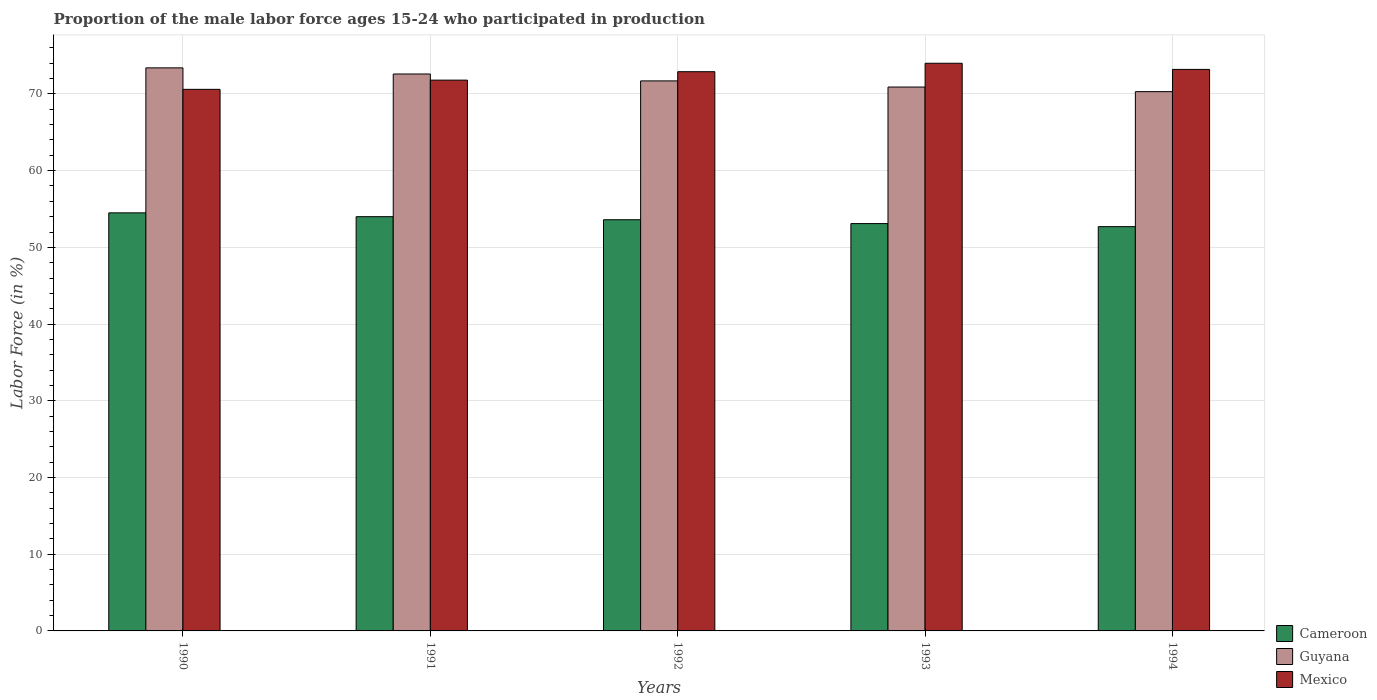How many different coloured bars are there?
Your answer should be very brief. 3. How many groups of bars are there?
Offer a very short reply. 5. Are the number of bars per tick equal to the number of legend labels?
Provide a succinct answer. Yes. Are the number of bars on each tick of the X-axis equal?
Your response must be concise. Yes. How many bars are there on the 4th tick from the right?
Your response must be concise. 3. In how many cases, is the number of bars for a given year not equal to the number of legend labels?
Your response must be concise. 0. What is the proportion of the male labor force who participated in production in Cameroon in 1992?
Your answer should be compact. 53.6. Across all years, what is the maximum proportion of the male labor force who participated in production in Guyana?
Your response must be concise. 73.4. Across all years, what is the minimum proportion of the male labor force who participated in production in Cameroon?
Ensure brevity in your answer.  52.7. In which year was the proportion of the male labor force who participated in production in Mexico minimum?
Your response must be concise. 1990. What is the total proportion of the male labor force who participated in production in Mexico in the graph?
Your answer should be compact. 362.5. What is the difference between the proportion of the male labor force who participated in production in Guyana in 1992 and that in 1993?
Your response must be concise. 0.8. What is the difference between the proportion of the male labor force who participated in production in Mexico in 1992 and the proportion of the male labor force who participated in production in Cameroon in 1990?
Keep it short and to the point. 18.4. What is the average proportion of the male labor force who participated in production in Mexico per year?
Provide a succinct answer. 72.5. In the year 1994, what is the difference between the proportion of the male labor force who participated in production in Guyana and proportion of the male labor force who participated in production in Cameroon?
Make the answer very short. 17.6. In how many years, is the proportion of the male labor force who participated in production in Mexico greater than 24 %?
Your answer should be compact. 5. What is the ratio of the proportion of the male labor force who participated in production in Guyana in 1990 to that in 1991?
Provide a short and direct response. 1.01. What is the difference between the highest and the lowest proportion of the male labor force who participated in production in Guyana?
Ensure brevity in your answer.  3.1. In how many years, is the proportion of the male labor force who participated in production in Mexico greater than the average proportion of the male labor force who participated in production in Mexico taken over all years?
Your response must be concise. 3. What does the 2nd bar from the left in 1993 represents?
Provide a succinct answer. Guyana. What does the 1st bar from the right in 1992 represents?
Provide a short and direct response. Mexico. Is it the case that in every year, the sum of the proportion of the male labor force who participated in production in Mexico and proportion of the male labor force who participated in production in Guyana is greater than the proportion of the male labor force who participated in production in Cameroon?
Your answer should be compact. Yes. How many bars are there?
Keep it short and to the point. 15. What is the difference between two consecutive major ticks on the Y-axis?
Your answer should be very brief. 10. Are the values on the major ticks of Y-axis written in scientific E-notation?
Your answer should be compact. No. Does the graph contain grids?
Offer a very short reply. Yes. Where does the legend appear in the graph?
Make the answer very short. Bottom right. How are the legend labels stacked?
Your answer should be compact. Vertical. What is the title of the graph?
Ensure brevity in your answer.  Proportion of the male labor force ages 15-24 who participated in production. Does "East Asia (developing only)" appear as one of the legend labels in the graph?
Ensure brevity in your answer.  No. What is the Labor Force (in %) in Cameroon in 1990?
Make the answer very short. 54.5. What is the Labor Force (in %) in Guyana in 1990?
Your answer should be compact. 73.4. What is the Labor Force (in %) in Mexico in 1990?
Provide a succinct answer. 70.6. What is the Labor Force (in %) in Cameroon in 1991?
Ensure brevity in your answer.  54. What is the Labor Force (in %) in Guyana in 1991?
Make the answer very short. 72.6. What is the Labor Force (in %) in Mexico in 1991?
Give a very brief answer. 71.8. What is the Labor Force (in %) in Cameroon in 1992?
Offer a terse response. 53.6. What is the Labor Force (in %) in Guyana in 1992?
Provide a succinct answer. 71.7. What is the Labor Force (in %) of Mexico in 1992?
Provide a short and direct response. 72.9. What is the Labor Force (in %) in Cameroon in 1993?
Your response must be concise. 53.1. What is the Labor Force (in %) of Guyana in 1993?
Offer a very short reply. 70.9. What is the Labor Force (in %) in Mexico in 1993?
Give a very brief answer. 74. What is the Labor Force (in %) of Cameroon in 1994?
Give a very brief answer. 52.7. What is the Labor Force (in %) in Guyana in 1994?
Offer a very short reply. 70.3. What is the Labor Force (in %) of Mexico in 1994?
Offer a very short reply. 73.2. Across all years, what is the maximum Labor Force (in %) in Cameroon?
Give a very brief answer. 54.5. Across all years, what is the maximum Labor Force (in %) of Guyana?
Ensure brevity in your answer.  73.4. Across all years, what is the minimum Labor Force (in %) in Cameroon?
Make the answer very short. 52.7. Across all years, what is the minimum Labor Force (in %) in Guyana?
Your answer should be very brief. 70.3. Across all years, what is the minimum Labor Force (in %) of Mexico?
Offer a terse response. 70.6. What is the total Labor Force (in %) in Cameroon in the graph?
Keep it short and to the point. 267.9. What is the total Labor Force (in %) in Guyana in the graph?
Offer a very short reply. 358.9. What is the total Labor Force (in %) of Mexico in the graph?
Your answer should be compact. 362.5. What is the difference between the Labor Force (in %) in Guyana in 1990 and that in 1991?
Your answer should be compact. 0.8. What is the difference between the Labor Force (in %) of Guyana in 1990 and that in 1992?
Make the answer very short. 1.7. What is the difference between the Labor Force (in %) in Mexico in 1990 and that in 1992?
Offer a very short reply. -2.3. What is the difference between the Labor Force (in %) of Cameroon in 1990 and that in 1993?
Offer a very short reply. 1.4. What is the difference between the Labor Force (in %) of Guyana in 1990 and that in 1993?
Keep it short and to the point. 2.5. What is the difference between the Labor Force (in %) of Mexico in 1990 and that in 1993?
Make the answer very short. -3.4. What is the difference between the Labor Force (in %) of Guyana in 1990 and that in 1994?
Your answer should be compact. 3.1. What is the difference between the Labor Force (in %) in Mexico in 1990 and that in 1994?
Ensure brevity in your answer.  -2.6. What is the difference between the Labor Force (in %) of Guyana in 1991 and that in 1992?
Offer a terse response. 0.9. What is the difference between the Labor Force (in %) of Mexico in 1991 and that in 1992?
Your response must be concise. -1.1. What is the difference between the Labor Force (in %) in Guyana in 1991 and that in 1993?
Your answer should be very brief. 1.7. What is the difference between the Labor Force (in %) in Cameroon in 1991 and that in 1994?
Your answer should be very brief. 1.3. What is the difference between the Labor Force (in %) in Guyana in 1991 and that in 1994?
Keep it short and to the point. 2.3. What is the difference between the Labor Force (in %) of Mexico in 1991 and that in 1994?
Give a very brief answer. -1.4. What is the difference between the Labor Force (in %) in Cameroon in 1992 and that in 1993?
Provide a succinct answer. 0.5. What is the difference between the Labor Force (in %) in Cameroon in 1993 and that in 1994?
Offer a very short reply. 0.4. What is the difference between the Labor Force (in %) of Guyana in 1993 and that in 1994?
Ensure brevity in your answer.  0.6. What is the difference between the Labor Force (in %) in Mexico in 1993 and that in 1994?
Your answer should be very brief. 0.8. What is the difference between the Labor Force (in %) of Cameroon in 1990 and the Labor Force (in %) of Guyana in 1991?
Provide a succinct answer. -18.1. What is the difference between the Labor Force (in %) of Cameroon in 1990 and the Labor Force (in %) of Mexico in 1991?
Ensure brevity in your answer.  -17.3. What is the difference between the Labor Force (in %) of Cameroon in 1990 and the Labor Force (in %) of Guyana in 1992?
Your response must be concise. -17.2. What is the difference between the Labor Force (in %) in Cameroon in 1990 and the Labor Force (in %) in Mexico in 1992?
Give a very brief answer. -18.4. What is the difference between the Labor Force (in %) in Cameroon in 1990 and the Labor Force (in %) in Guyana in 1993?
Give a very brief answer. -16.4. What is the difference between the Labor Force (in %) of Cameroon in 1990 and the Labor Force (in %) of Mexico in 1993?
Your response must be concise. -19.5. What is the difference between the Labor Force (in %) of Cameroon in 1990 and the Labor Force (in %) of Guyana in 1994?
Offer a terse response. -15.8. What is the difference between the Labor Force (in %) in Cameroon in 1990 and the Labor Force (in %) in Mexico in 1994?
Keep it short and to the point. -18.7. What is the difference between the Labor Force (in %) in Cameroon in 1991 and the Labor Force (in %) in Guyana in 1992?
Provide a short and direct response. -17.7. What is the difference between the Labor Force (in %) in Cameroon in 1991 and the Labor Force (in %) in Mexico in 1992?
Ensure brevity in your answer.  -18.9. What is the difference between the Labor Force (in %) of Guyana in 1991 and the Labor Force (in %) of Mexico in 1992?
Provide a succinct answer. -0.3. What is the difference between the Labor Force (in %) in Cameroon in 1991 and the Labor Force (in %) in Guyana in 1993?
Your response must be concise. -16.9. What is the difference between the Labor Force (in %) in Guyana in 1991 and the Labor Force (in %) in Mexico in 1993?
Keep it short and to the point. -1.4. What is the difference between the Labor Force (in %) of Cameroon in 1991 and the Labor Force (in %) of Guyana in 1994?
Ensure brevity in your answer.  -16.3. What is the difference between the Labor Force (in %) in Cameroon in 1991 and the Labor Force (in %) in Mexico in 1994?
Your answer should be very brief. -19.2. What is the difference between the Labor Force (in %) in Guyana in 1991 and the Labor Force (in %) in Mexico in 1994?
Give a very brief answer. -0.6. What is the difference between the Labor Force (in %) in Cameroon in 1992 and the Labor Force (in %) in Guyana in 1993?
Provide a short and direct response. -17.3. What is the difference between the Labor Force (in %) of Cameroon in 1992 and the Labor Force (in %) of Mexico in 1993?
Offer a terse response. -20.4. What is the difference between the Labor Force (in %) of Cameroon in 1992 and the Labor Force (in %) of Guyana in 1994?
Provide a succinct answer. -16.7. What is the difference between the Labor Force (in %) in Cameroon in 1992 and the Labor Force (in %) in Mexico in 1994?
Your answer should be compact. -19.6. What is the difference between the Labor Force (in %) in Cameroon in 1993 and the Labor Force (in %) in Guyana in 1994?
Provide a succinct answer. -17.2. What is the difference between the Labor Force (in %) in Cameroon in 1993 and the Labor Force (in %) in Mexico in 1994?
Provide a succinct answer. -20.1. What is the difference between the Labor Force (in %) in Guyana in 1993 and the Labor Force (in %) in Mexico in 1994?
Ensure brevity in your answer.  -2.3. What is the average Labor Force (in %) in Cameroon per year?
Your answer should be very brief. 53.58. What is the average Labor Force (in %) in Guyana per year?
Your answer should be very brief. 71.78. What is the average Labor Force (in %) of Mexico per year?
Offer a terse response. 72.5. In the year 1990, what is the difference between the Labor Force (in %) of Cameroon and Labor Force (in %) of Guyana?
Your answer should be compact. -18.9. In the year 1990, what is the difference between the Labor Force (in %) of Cameroon and Labor Force (in %) of Mexico?
Give a very brief answer. -16.1. In the year 1990, what is the difference between the Labor Force (in %) of Guyana and Labor Force (in %) of Mexico?
Provide a succinct answer. 2.8. In the year 1991, what is the difference between the Labor Force (in %) of Cameroon and Labor Force (in %) of Guyana?
Your answer should be compact. -18.6. In the year 1991, what is the difference between the Labor Force (in %) of Cameroon and Labor Force (in %) of Mexico?
Your answer should be very brief. -17.8. In the year 1992, what is the difference between the Labor Force (in %) of Cameroon and Labor Force (in %) of Guyana?
Ensure brevity in your answer.  -18.1. In the year 1992, what is the difference between the Labor Force (in %) in Cameroon and Labor Force (in %) in Mexico?
Ensure brevity in your answer.  -19.3. In the year 1993, what is the difference between the Labor Force (in %) in Cameroon and Labor Force (in %) in Guyana?
Give a very brief answer. -17.8. In the year 1993, what is the difference between the Labor Force (in %) of Cameroon and Labor Force (in %) of Mexico?
Ensure brevity in your answer.  -20.9. In the year 1994, what is the difference between the Labor Force (in %) in Cameroon and Labor Force (in %) in Guyana?
Ensure brevity in your answer.  -17.6. In the year 1994, what is the difference between the Labor Force (in %) of Cameroon and Labor Force (in %) of Mexico?
Ensure brevity in your answer.  -20.5. In the year 1994, what is the difference between the Labor Force (in %) of Guyana and Labor Force (in %) of Mexico?
Give a very brief answer. -2.9. What is the ratio of the Labor Force (in %) of Cameroon in 1990 to that in 1991?
Provide a succinct answer. 1.01. What is the ratio of the Labor Force (in %) of Guyana in 1990 to that in 1991?
Ensure brevity in your answer.  1.01. What is the ratio of the Labor Force (in %) in Mexico in 1990 to that in 1991?
Provide a short and direct response. 0.98. What is the ratio of the Labor Force (in %) in Cameroon in 1990 to that in 1992?
Offer a very short reply. 1.02. What is the ratio of the Labor Force (in %) of Guyana in 1990 to that in 1992?
Offer a terse response. 1.02. What is the ratio of the Labor Force (in %) in Mexico in 1990 to that in 1992?
Provide a succinct answer. 0.97. What is the ratio of the Labor Force (in %) in Cameroon in 1990 to that in 1993?
Keep it short and to the point. 1.03. What is the ratio of the Labor Force (in %) of Guyana in 1990 to that in 1993?
Make the answer very short. 1.04. What is the ratio of the Labor Force (in %) of Mexico in 1990 to that in 1993?
Keep it short and to the point. 0.95. What is the ratio of the Labor Force (in %) in Cameroon in 1990 to that in 1994?
Ensure brevity in your answer.  1.03. What is the ratio of the Labor Force (in %) in Guyana in 1990 to that in 1994?
Offer a very short reply. 1.04. What is the ratio of the Labor Force (in %) of Mexico in 1990 to that in 1994?
Offer a terse response. 0.96. What is the ratio of the Labor Force (in %) of Cameroon in 1991 to that in 1992?
Offer a very short reply. 1.01. What is the ratio of the Labor Force (in %) of Guyana in 1991 to that in 1992?
Provide a short and direct response. 1.01. What is the ratio of the Labor Force (in %) of Mexico in 1991 to that in 1992?
Provide a succinct answer. 0.98. What is the ratio of the Labor Force (in %) of Cameroon in 1991 to that in 1993?
Ensure brevity in your answer.  1.02. What is the ratio of the Labor Force (in %) in Mexico in 1991 to that in 1993?
Offer a terse response. 0.97. What is the ratio of the Labor Force (in %) in Cameroon in 1991 to that in 1994?
Provide a succinct answer. 1.02. What is the ratio of the Labor Force (in %) in Guyana in 1991 to that in 1994?
Your response must be concise. 1.03. What is the ratio of the Labor Force (in %) in Mexico in 1991 to that in 1994?
Offer a terse response. 0.98. What is the ratio of the Labor Force (in %) in Cameroon in 1992 to that in 1993?
Your answer should be very brief. 1.01. What is the ratio of the Labor Force (in %) of Guyana in 1992 to that in 1993?
Provide a succinct answer. 1.01. What is the ratio of the Labor Force (in %) in Mexico in 1992 to that in 1993?
Your answer should be compact. 0.99. What is the ratio of the Labor Force (in %) of Cameroon in 1992 to that in 1994?
Your answer should be very brief. 1.02. What is the ratio of the Labor Force (in %) of Guyana in 1992 to that in 1994?
Give a very brief answer. 1.02. What is the ratio of the Labor Force (in %) in Mexico in 1992 to that in 1994?
Provide a succinct answer. 1. What is the ratio of the Labor Force (in %) of Cameroon in 1993 to that in 1994?
Offer a very short reply. 1.01. What is the ratio of the Labor Force (in %) in Guyana in 1993 to that in 1994?
Give a very brief answer. 1.01. What is the ratio of the Labor Force (in %) in Mexico in 1993 to that in 1994?
Your answer should be compact. 1.01. What is the difference between the highest and the second highest Labor Force (in %) of Cameroon?
Offer a very short reply. 0.5. What is the difference between the highest and the second highest Labor Force (in %) of Guyana?
Keep it short and to the point. 0.8. What is the difference between the highest and the lowest Labor Force (in %) of Guyana?
Your answer should be very brief. 3.1. What is the difference between the highest and the lowest Labor Force (in %) in Mexico?
Your answer should be very brief. 3.4. 